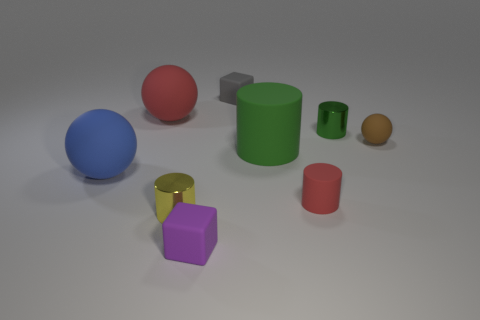Subtract all blue balls. How many balls are left? 2 Subtract all gray blocks. How many blocks are left? 1 Subtract all spheres. How many objects are left? 6 Subtract all green spheres. How many gray blocks are left? 1 Subtract all green cylinders. Subtract all cyan spheres. How many objects are left? 7 Add 1 red spheres. How many red spheres are left? 2 Add 9 big cylinders. How many big cylinders exist? 10 Subtract 0 yellow blocks. How many objects are left? 9 Subtract 3 cylinders. How many cylinders are left? 1 Subtract all red balls. Subtract all brown cubes. How many balls are left? 2 